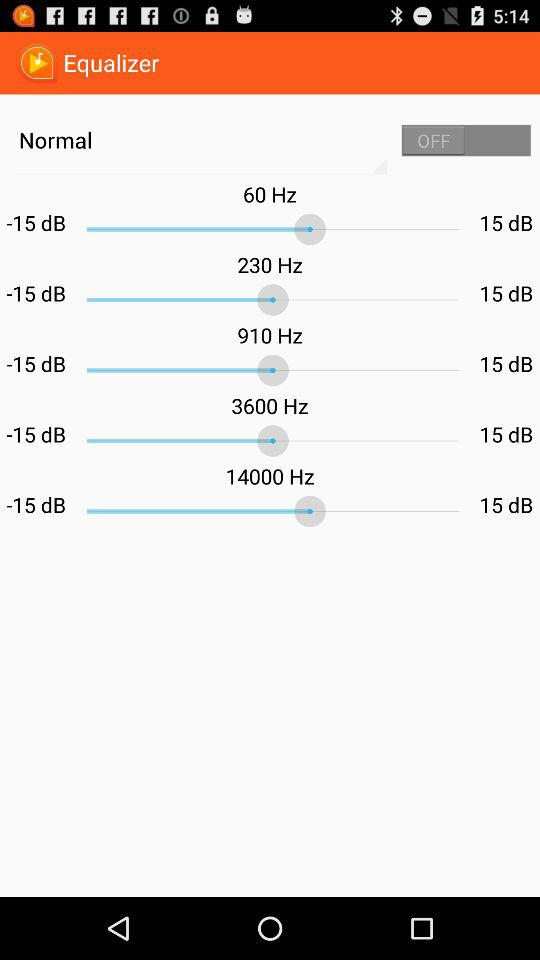Which audio file is playing now?
When the provided information is insufficient, respond with <no answer>. <no answer> 